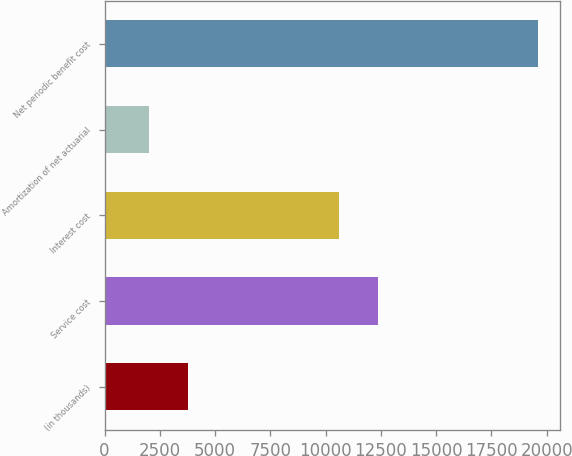Convert chart. <chart><loc_0><loc_0><loc_500><loc_500><bar_chart><fcel>(in thousands)<fcel>Service cost<fcel>Interest cost<fcel>Amortization of net actuarial<fcel>Net periodic benefit cost<nl><fcel>3756<fcel>12361<fcel>10600<fcel>1995<fcel>19605<nl></chart> 